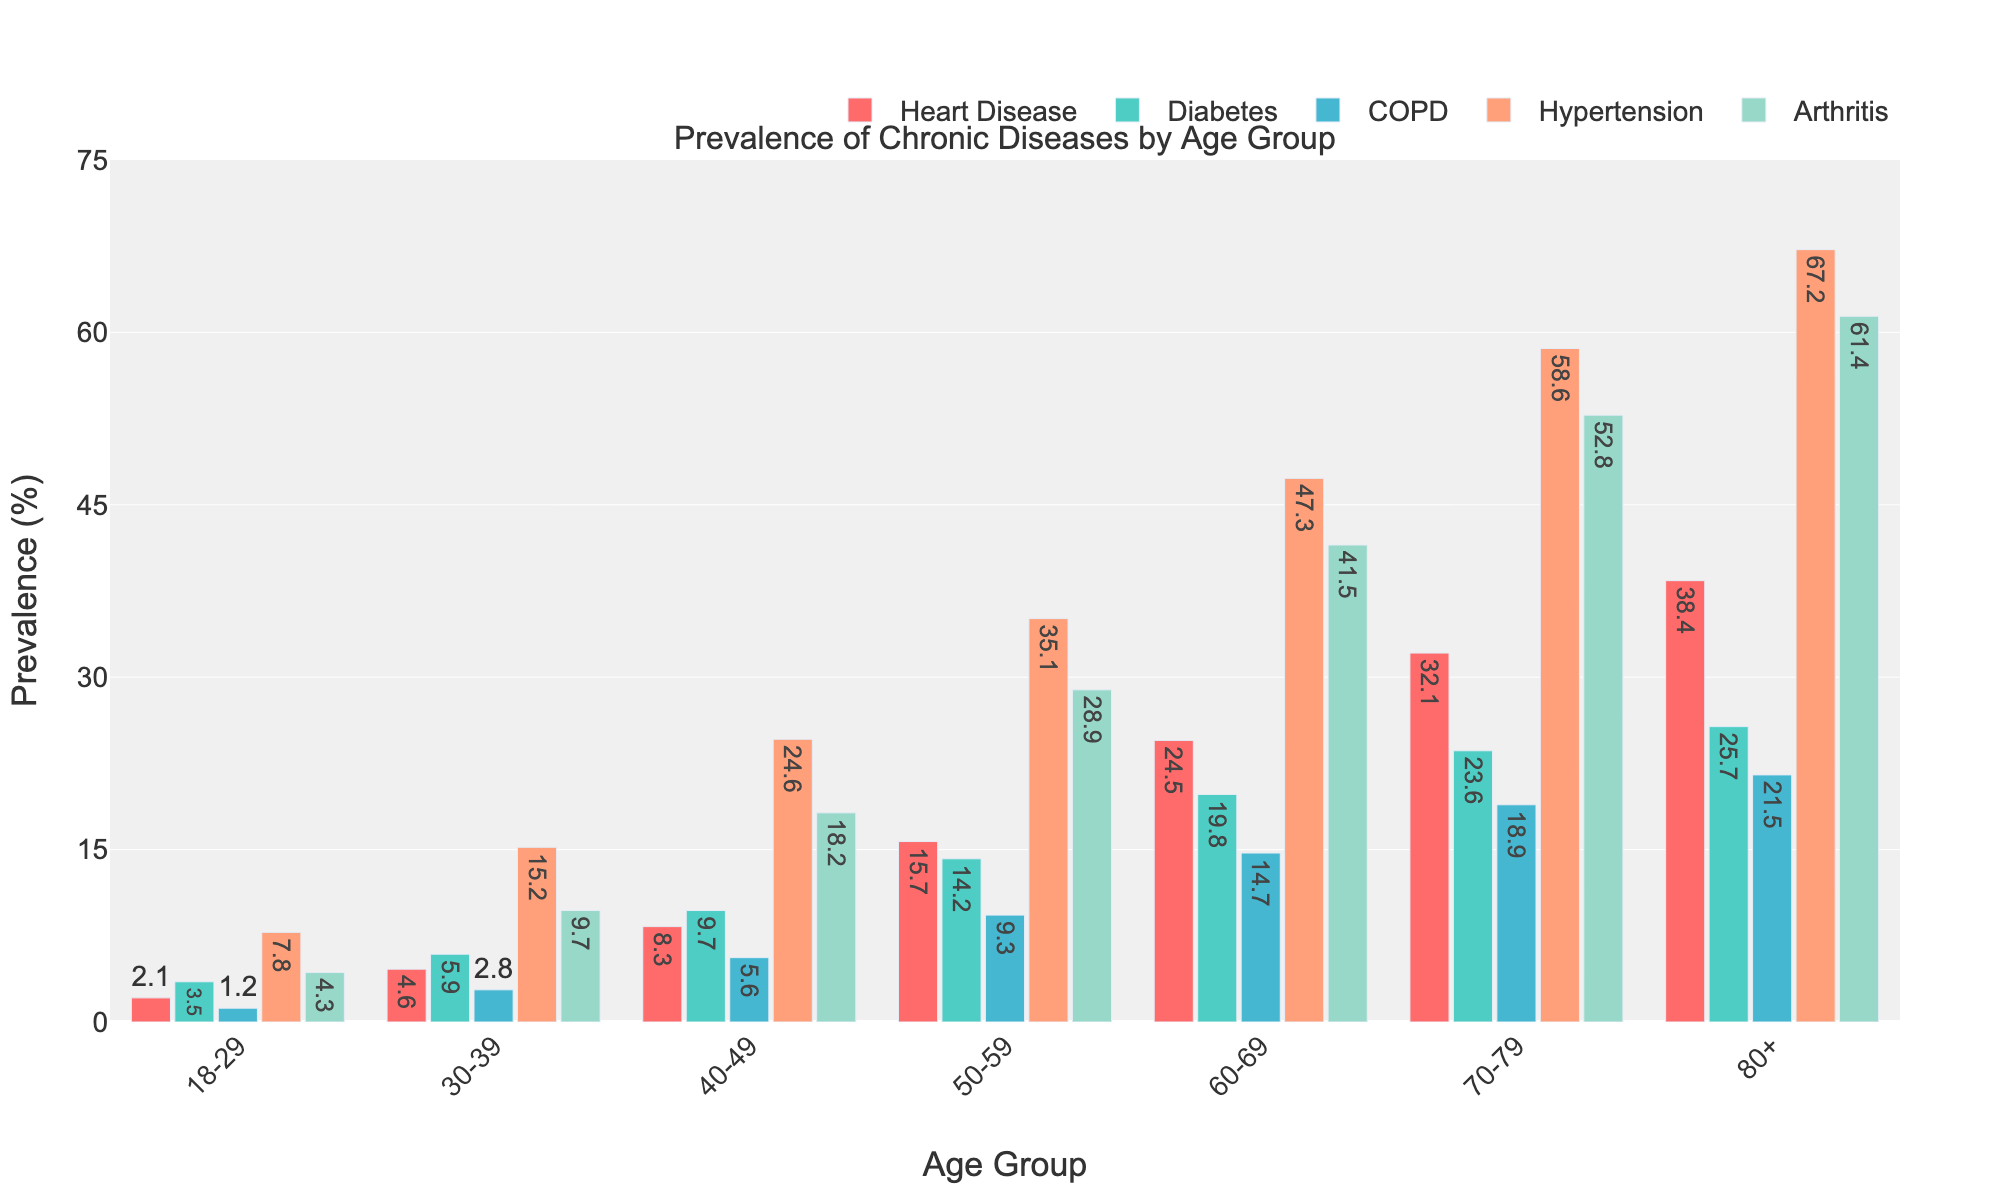What is the prevalence of arthritis in the 70-79 age group? The bar corresponding to Arthritis in the 70-79 age group shows a height of 52.8, indicating the percentage.
Answer: 52.8% Which age group has the highest prevalence of heart disease? Observing the bars, the 80+ age group has the tallest bar for heart disease, indicating 38.4%.
Answer: 80+ What is the difference in diabetes prevalence between the 40-49 and 50-59 age groups? The prevalence of diabetes is 9.7% in the 40-49 age group and 14.2% in the 50-59 age group. The difference is calculated as 14.2 - 9.7 = 4.5.
Answer: 4.5% Among the chronic diseases, which one is most prevalent in the 18-29 age group? Examining the bars for the 18-29 age group, Hypertension has the highest bar at 7.8%.
Answer: Hypertension What is the average prevalence of COPD across all age groups? To calculate the average, sum the prevalence values for COPD across all age groups: 1.2 + 2.8 + 5.6 + 9.3 + 14.7 + 18.9 + 21.5 = 74. Then, divide by the number of age groups: 74 / 7 ≈ 10.57.
Answer: 10.57% How does the prevalence of hypertension in the 60-69 age group compare to the 70-79 age group? The prevalence of hypertension is 47.3% in the 60-69 age group and 58.6% in the 70-79 age group. 58.6% is greater than 47.3%.
Answer: Greater in 70-79 Which disease shows a consistent increase in prevalence across all age groups? Observing each bar for every age group, Heart Disease, Diabetes, COPD, Hypertension, and Arthritis all show an upward trend.
Answer: All diseases shown In the 50-59 age group, which chronic disease has the lowest prevalence? Looking at the bars, COPD has the shortest bar at 9.3% in the 50-59 age group.
Answer: COPD What is the summed prevalence of all chronic diseases in the 30-39 age group? Sum the prevalence values: 4.6 (Heart Disease) + 5.9 (Diabetes) + 2.8 (COPD) + 15.2 (Hypertension) + 9.7 (Arthritis) = 38.2.
Answer: 38.2% Which age group experiences the steepest increase in prevalence of arthritis from the previous age group? Observing the changes, the biggest increase in arthritis prevalence happens from 60-69 (41.5%) to 70-79 (52.8%), which is an 11.3% increase.
Answer: 60-69 to 70-79 